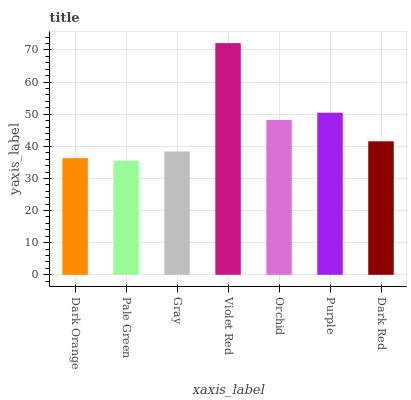Is Pale Green the minimum?
Answer yes or no. Yes. Is Violet Red the maximum?
Answer yes or no. Yes. Is Gray the minimum?
Answer yes or no. No. Is Gray the maximum?
Answer yes or no. No. Is Gray greater than Pale Green?
Answer yes or no. Yes. Is Pale Green less than Gray?
Answer yes or no. Yes. Is Pale Green greater than Gray?
Answer yes or no. No. Is Gray less than Pale Green?
Answer yes or no. No. Is Dark Red the high median?
Answer yes or no. Yes. Is Dark Red the low median?
Answer yes or no. Yes. Is Dark Orange the high median?
Answer yes or no. No. Is Purple the low median?
Answer yes or no. No. 